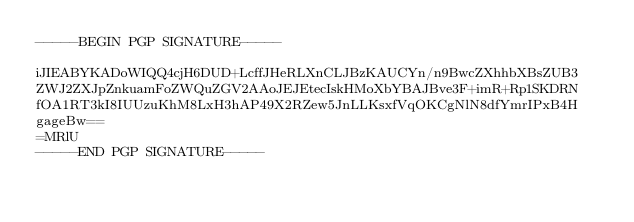Convert code to text. <code><loc_0><loc_0><loc_500><loc_500><_SML_>-----BEGIN PGP SIGNATURE-----

iJIEABYKADoWIQQ4cjH6DUD+LcffJHeRLXnCLJBzKAUCYn/n9BwcZXhhbXBsZUB3
ZWJ2ZXJpZnkuamFoZWQuZGV2AAoJEJEtecIskHMoXbYBAJBve3F+imR+Rp1SKDRN
fOA1RT3kI8IUUzuKhM8LxH3hAP49X2RZew5JnLLKsxfVqOKCgNlN8dfYmrIPxB4H
gageBw==
=MRlU
-----END PGP SIGNATURE-----
</code> 